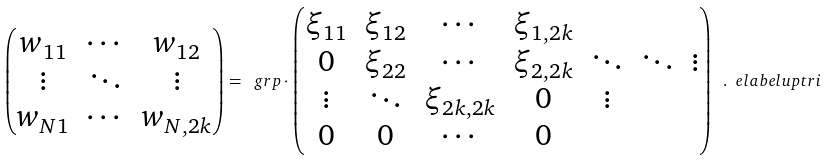<formula> <loc_0><loc_0><loc_500><loc_500>\begin{pmatrix} w _ { 1 1 } & \cdots & w _ { 1 2 } \\ \vdots & \ddots & \vdots \\ w _ { N 1 } & \cdots & w _ { N , 2 k } \end{pmatrix} = \ g r p \cdot \begin{pmatrix} \xi _ { 1 1 } & \xi _ { 1 2 } & \cdots & \xi _ { 1 , 2 k } \\ 0 & \xi _ { 2 2 } & \cdots & \xi _ { 2 , 2 k } & \ddots & \ddots & \vdots \\ \vdots & \ddots & \xi _ { 2 k , 2 k } & 0 & \vdots \\ 0 & 0 & \cdots & 0 \end{pmatrix} \ . \ e l a b e l { u p t r i }</formula> 